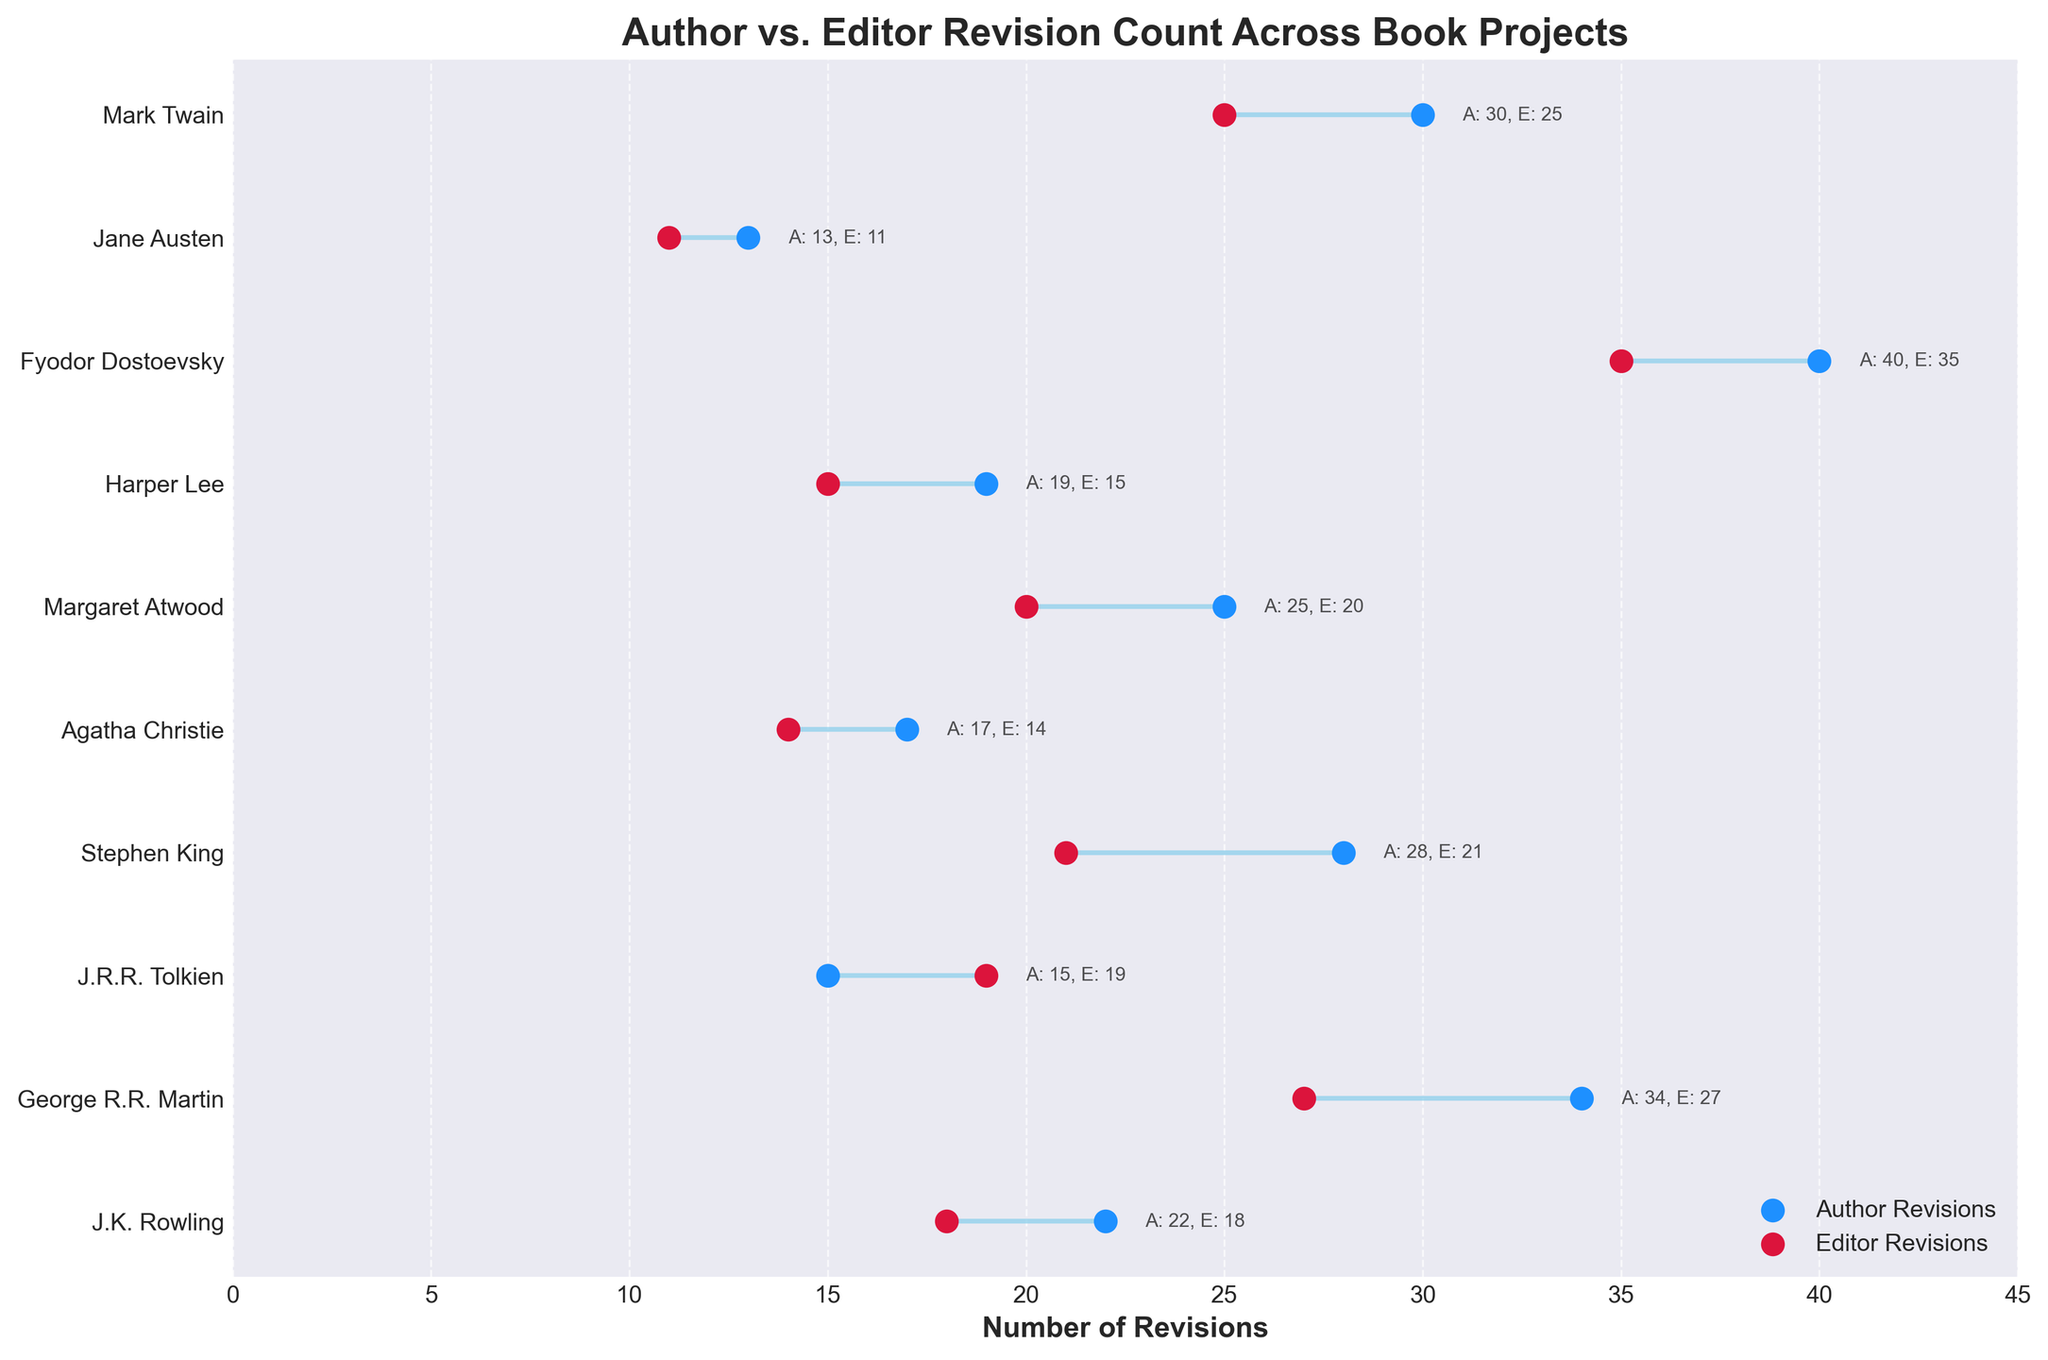What's the title of the figure? The title of the figure is displayed at the top in bold letters. It summarizes what the figure represents.
Answer: "Author vs. Editor Revision Count Across Book Projects" Which author had the least number of revisions by the editor? By inspecting the lengths of each horizontal bar and their corresponding labels, we can determine the shortest editor revision count.
Answer: Jane Austen How many more revisions did George R.R. Martin have compared to the editor? Subtract the editor revisions from the author's revisions for George R.R. Martin. Calculation: 34 - 27 = 7
Answer: 7 Which book project had the greatest difference in revisions between author and editor? Identify the longest horizontal bar by comparing the differences across the figure. Fyodor Dostoevsky's "Crime and Punishment" has the longest bar. Calculation of difference: 40 - 35 = 5
Answer: Fyodor Dostoevsky On which book did the editor have more revisions than the author? Compare both revision points for all books. J.R.R. Tolkien's "The Hobbit" is the only one where the editor revisions (19) are more than the author revisions (15).
Answer: J.R.R. Tolkien What is the average number of revisions for authors? Sum up all the author revisions and divide by the number of authors (10). Calculation: (22 + 34 + 15 + 28 + 17 + 25 + 19 + 40 + 13 + 30) / 10 = 24.3
Answer: 24.3 Compare the total number of revisions for Stephen King and Agatha Christie. Who had more revisions? Add up the author and editor revisions for each and compare. Stephen King: 28 + 21 = 49, Agatha Christie: 17 + 14 = 31. Stephen King has more.
Answer: Stephen King What is the total number of revisions made by all the editors combined? Sum up all the editor revisions. Calculation: 18 + 27 + 19 + 21 + 14 + 20 + 15 + 35 + 11 + 25 = 205
Answer: 205 Which book projects have editor revisions less than 20? Check the editor revision values for all book projects and list those less than 20. These are: "Harry Potter and the Philosopher's Stone", "The Hobbit", "Murder on the Orient Express", "To Kill a Mockingbird", "Pride and Prejudice".
Answer: "Harry Potter and the Philosopher's Stone", "The Hobbit", "Murder on the Orient Express", "To Kill a Mockingbird", "Pride and Prejudice" What are the individual revisions of Jane Austen's "Pride and Prejudice"? Look at the specific labels next to the dots for Jane Austen. It shows "A: 13, E: 11".
Answer: "A: 13, E: 11" 